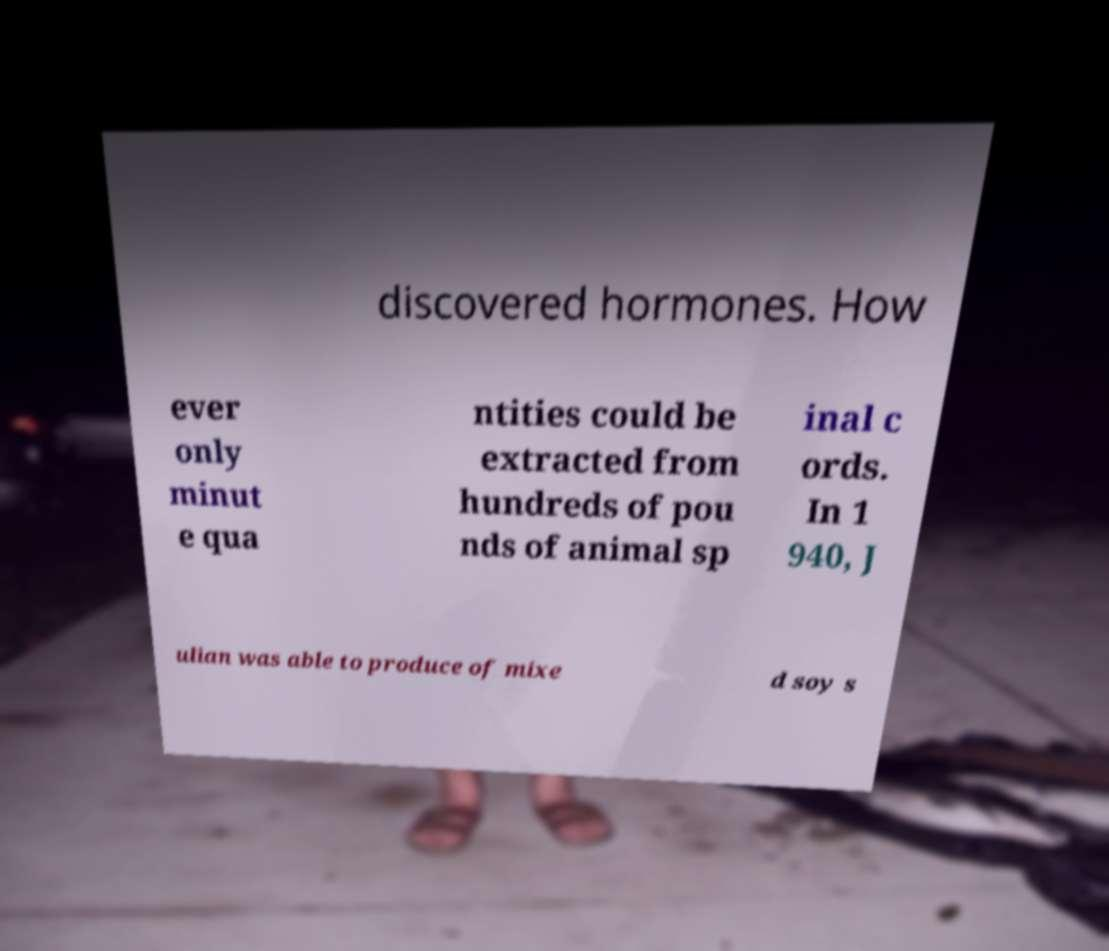What messages or text are displayed in this image? I need them in a readable, typed format. discovered hormones. How ever only minut e qua ntities could be extracted from hundreds of pou nds of animal sp inal c ords. In 1 940, J ulian was able to produce of mixe d soy s 